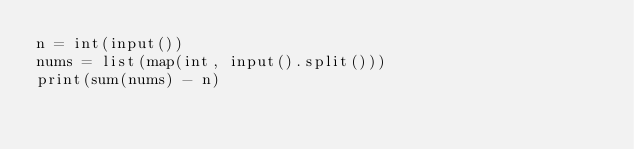Convert code to text. <code><loc_0><loc_0><loc_500><loc_500><_Python_>n = int(input())
nums = list(map(int, input().split()))
print(sum(nums) - n)
</code> 